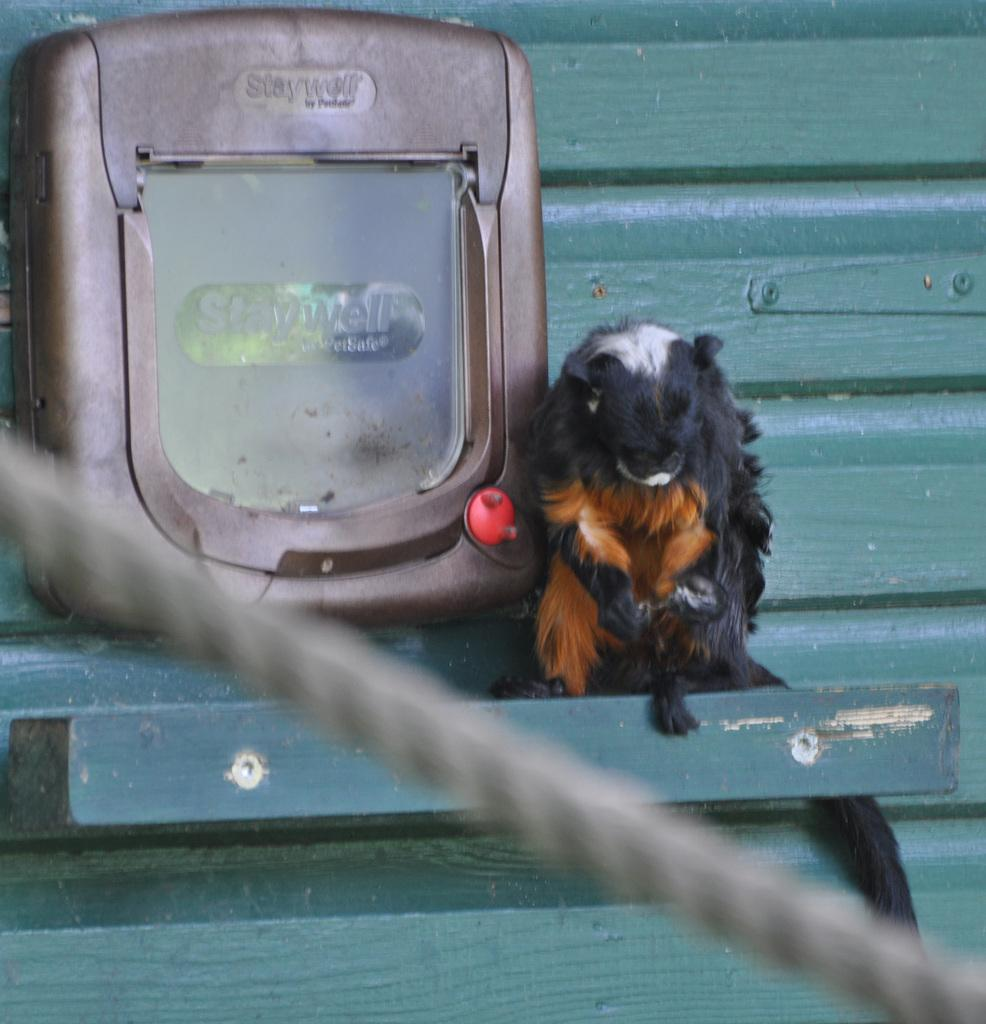What is the primary object in the image? There is a thread in the image. What is the thread attached to in the image? There is an object attached to a green surface in the image. What type of animal can be seen on the green surface? There is an animal on the green surface in the image. What type of paper is being exchanged between the animal and the object in the image? There is no paper present in the image, nor is there any indication of an exchange taking place. 